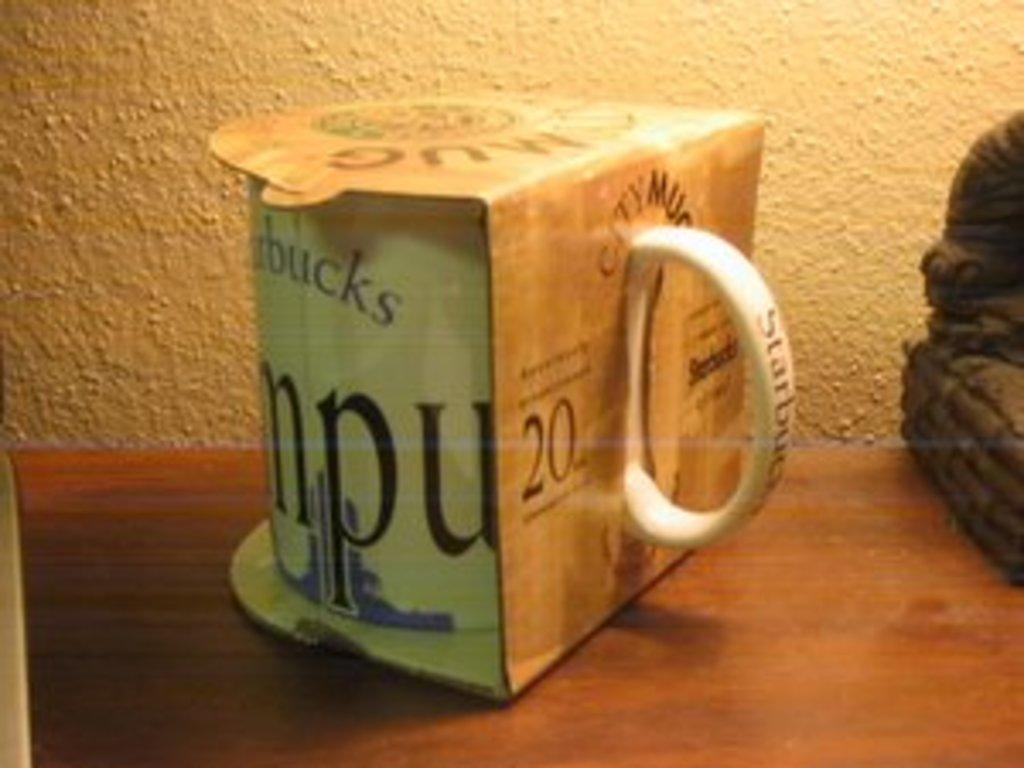What is the main object in the image? There is a cup in the image. Where is the cup located? The cup is in a box made of paper. What can be seen in the background of the image? There is a wall in the image. How many mice are hiding behind the wall in the image? There are no mice present in the image; it only features a cup in a paper box and a wall in the background. 